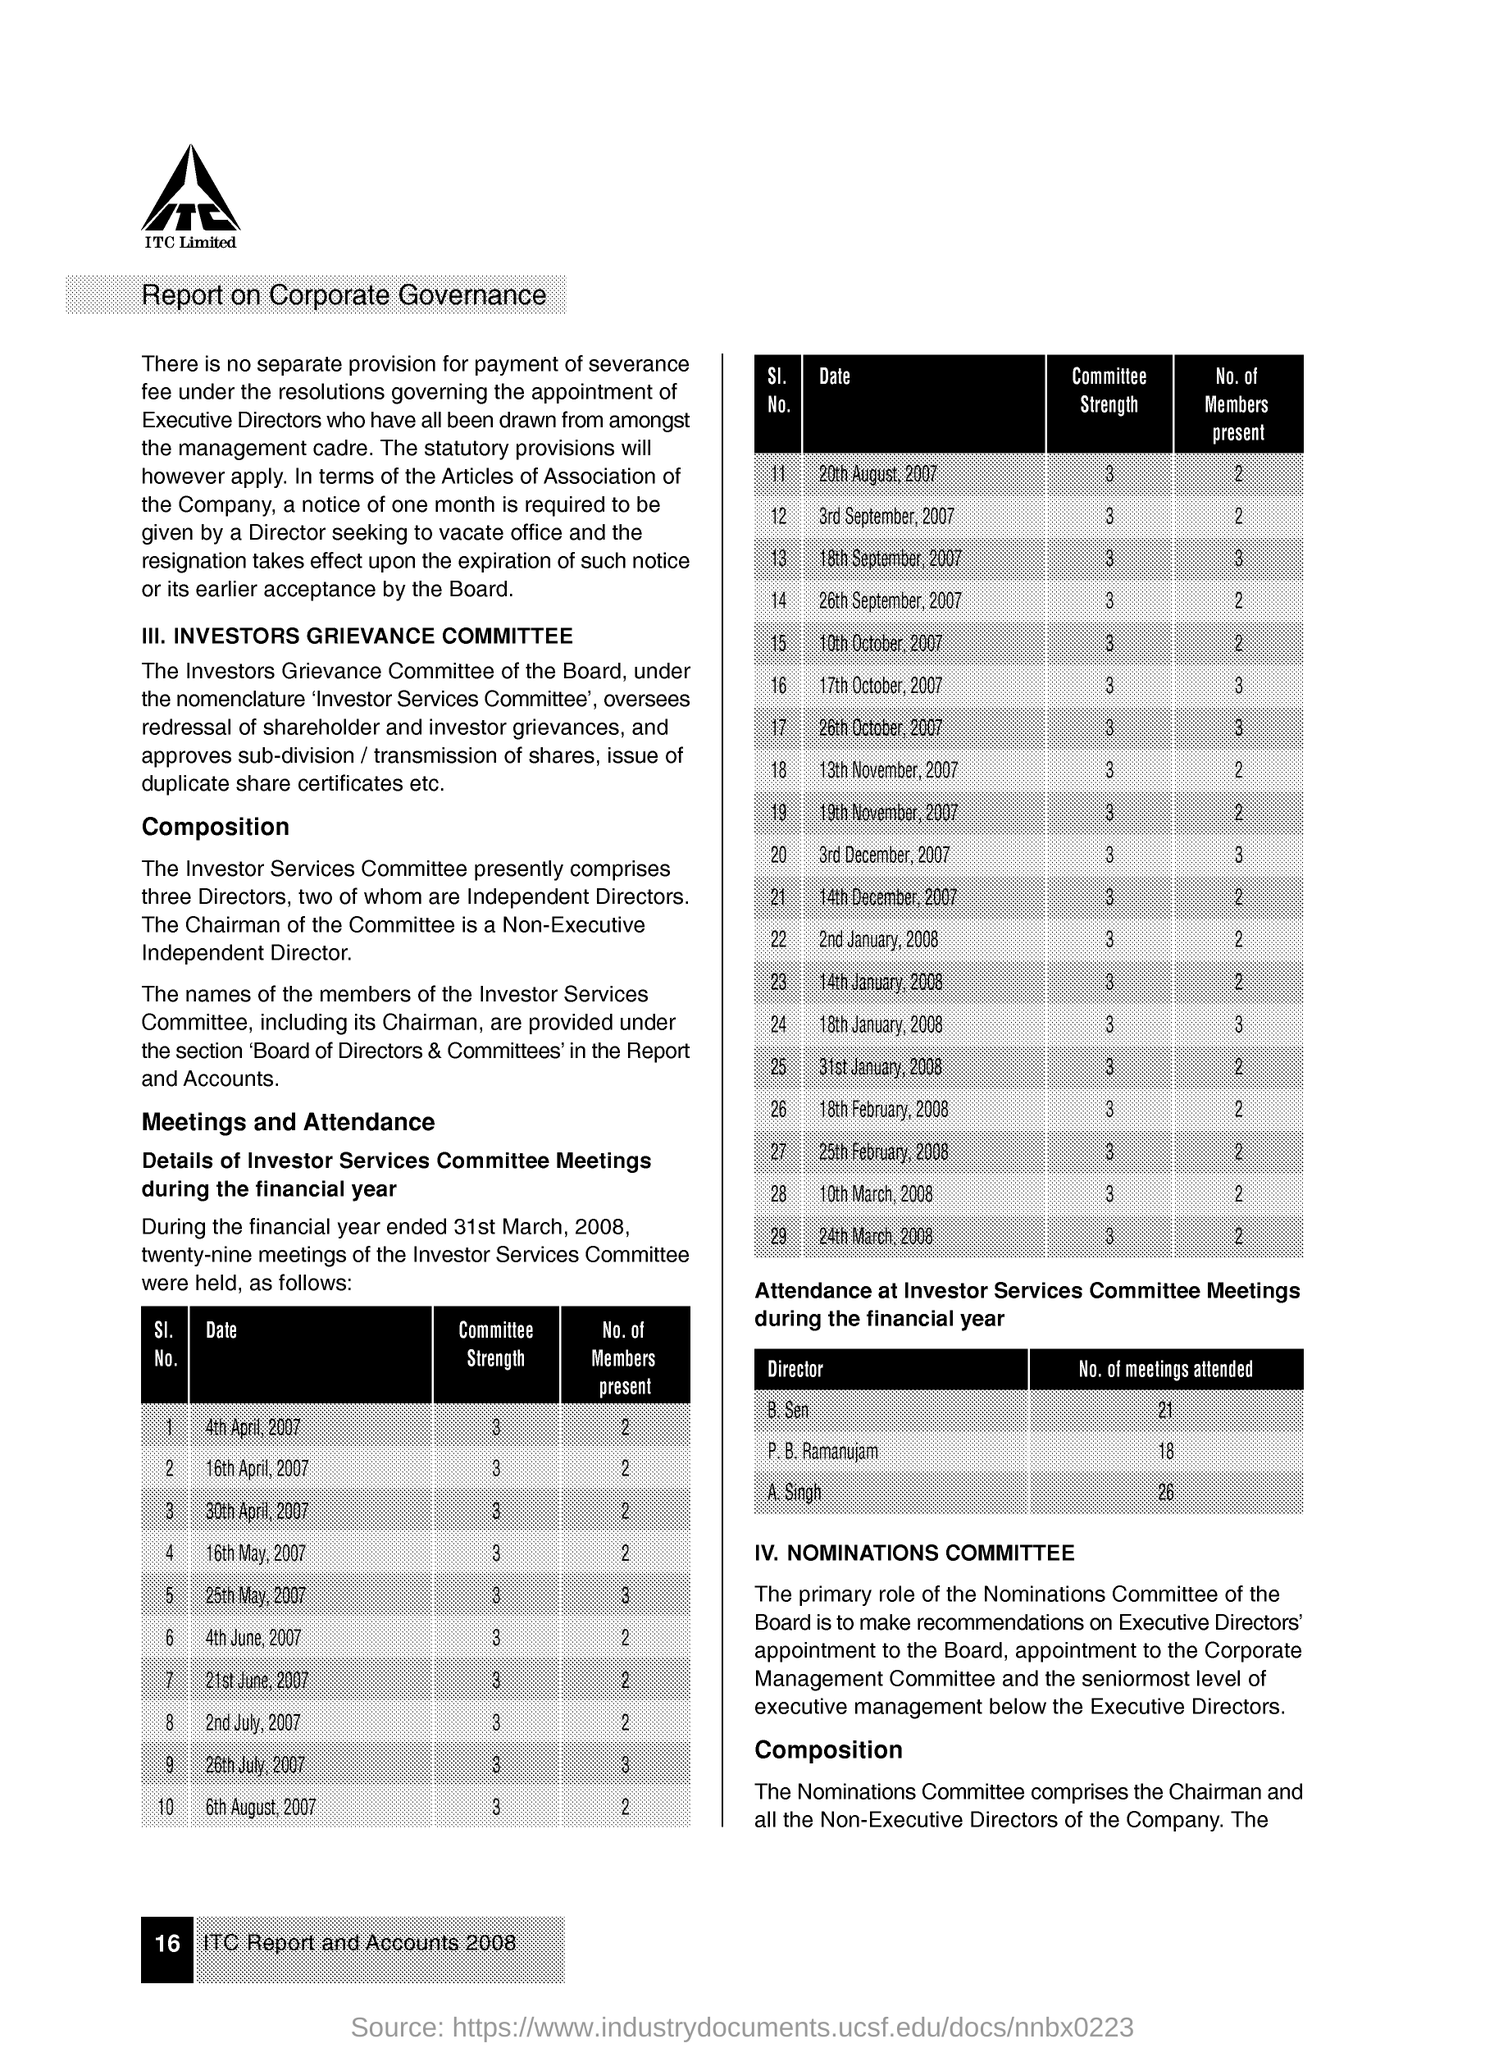What is the committee strength on 20th august , 2007
Ensure brevity in your answer.  3. How many members were present for the investors service committee meetings on 18th january ,2008
Keep it short and to the point. 3. How many meetings did b. sen has attended
Your response must be concise. 21. What is the committee strength as on 16th april, 2007
Ensure brevity in your answer.  3. How many members were present for the investors service committee meetings on 21st june, 2007
Your answer should be compact. 2. What is the committee strength as on 3rd december , 2007
Ensure brevity in your answer.  3. 